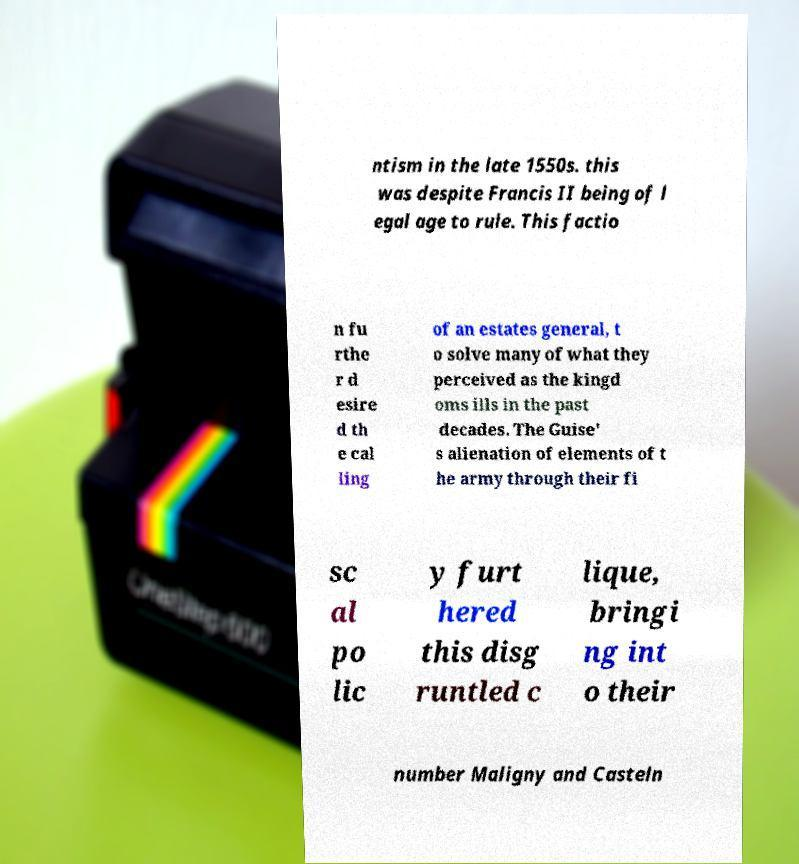I need the written content from this picture converted into text. Can you do that? ntism in the late 1550s. this was despite Francis II being of l egal age to rule. This factio n fu rthe r d esire d th e cal ling of an estates general, t o solve many of what they perceived as the kingd oms ills in the past decades. The Guise' s alienation of elements of t he army through their fi sc al po lic y furt hered this disg runtled c lique, bringi ng int o their number Maligny and Casteln 